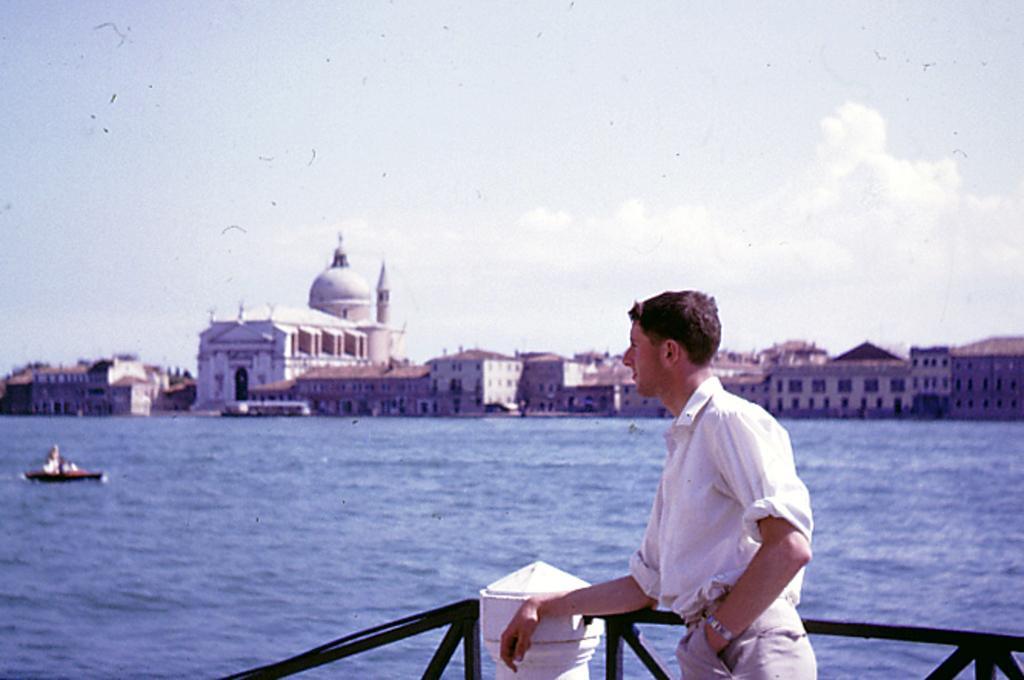In one or two sentences, can you explain what this image depicts? In this picture we can see a man standing at fence and a boat on water and in the background we can see buildings with windows, sky with clouds. 